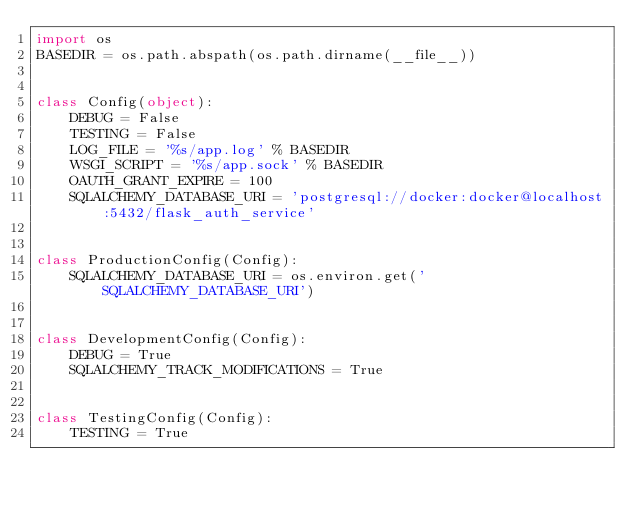Convert code to text. <code><loc_0><loc_0><loc_500><loc_500><_Python_>import os
BASEDIR = os.path.abspath(os.path.dirname(__file__))


class Config(object):
    DEBUG = False
    TESTING = False
    LOG_FILE = '%s/app.log' % BASEDIR
    WSGI_SCRIPT = '%s/app.sock' % BASEDIR
    OAUTH_GRANT_EXPIRE = 100
    SQLALCHEMY_DATABASE_URI = 'postgresql://docker:docker@localhost:5432/flask_auth_service'


class ProductionConfig(Config):
    SQLALCHEMY_DATABASE_URI = os.environ.get('SQLALCHEMY_DATABASE_URI')


class DevelopmentConfig(Config):
    DEBUG = True
    SQLALCHEMY_TRACK_MODIFICATIONS = True


class TestingConfig(Config):
    TESTING = True
</code> 